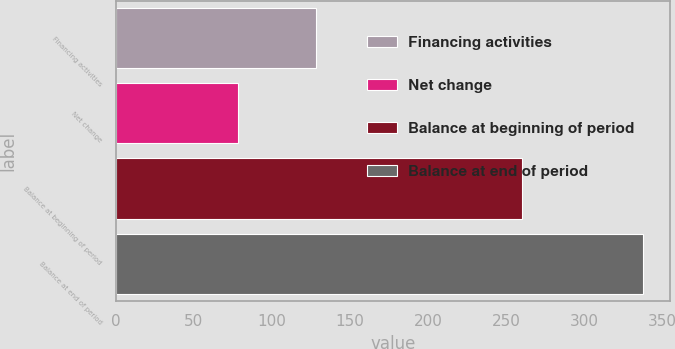<chart> <loc_0><loc_0><loc_500><loc_500><bar_chart><fcel>Financing activities<fcel>Net change<fcel>Balance at beginning of period<fcel>Balance at end of period<nl><fcel>128<fcel>78<fcel>260<fcel>338<nl></chart> 